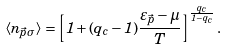Convert formula to latex. <formula><loc_0><loc_0><loc_500><loc_500>\langle n _ { \vec { p } \sigma } \rangle = \left [ 1 + ( q _ { c } - 1 ) \frac { \varepsilon _ { \vec { p } } - \mu } { T } \right ] ^ { \frac { q _ { c } } { 1 - q _ { c } } } .</formula> 